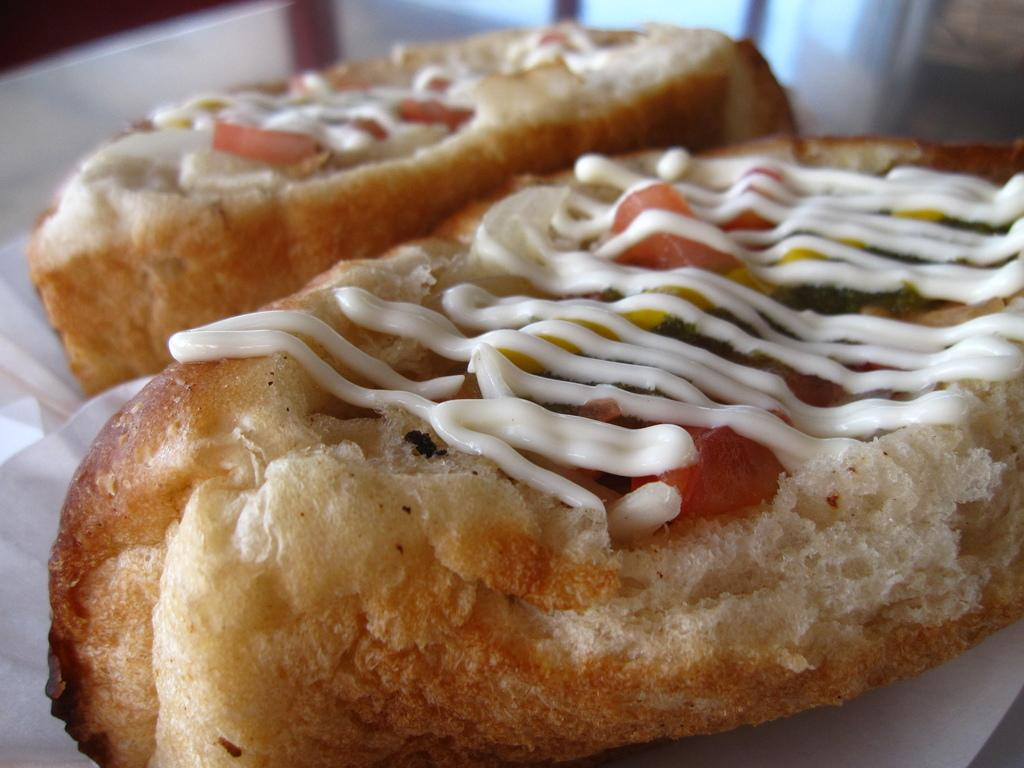What color is the food in the image? The food in the image is brown-colored. What is on top of the food? There is a white-colored thing on the food. How would you describe the overall clarity of the image? The image is slightly blurry in the background. What type of sky is visible in the image? There is no sky visible in the image; it is focused on the brown-colored food and the white-colored thing on top of it. 